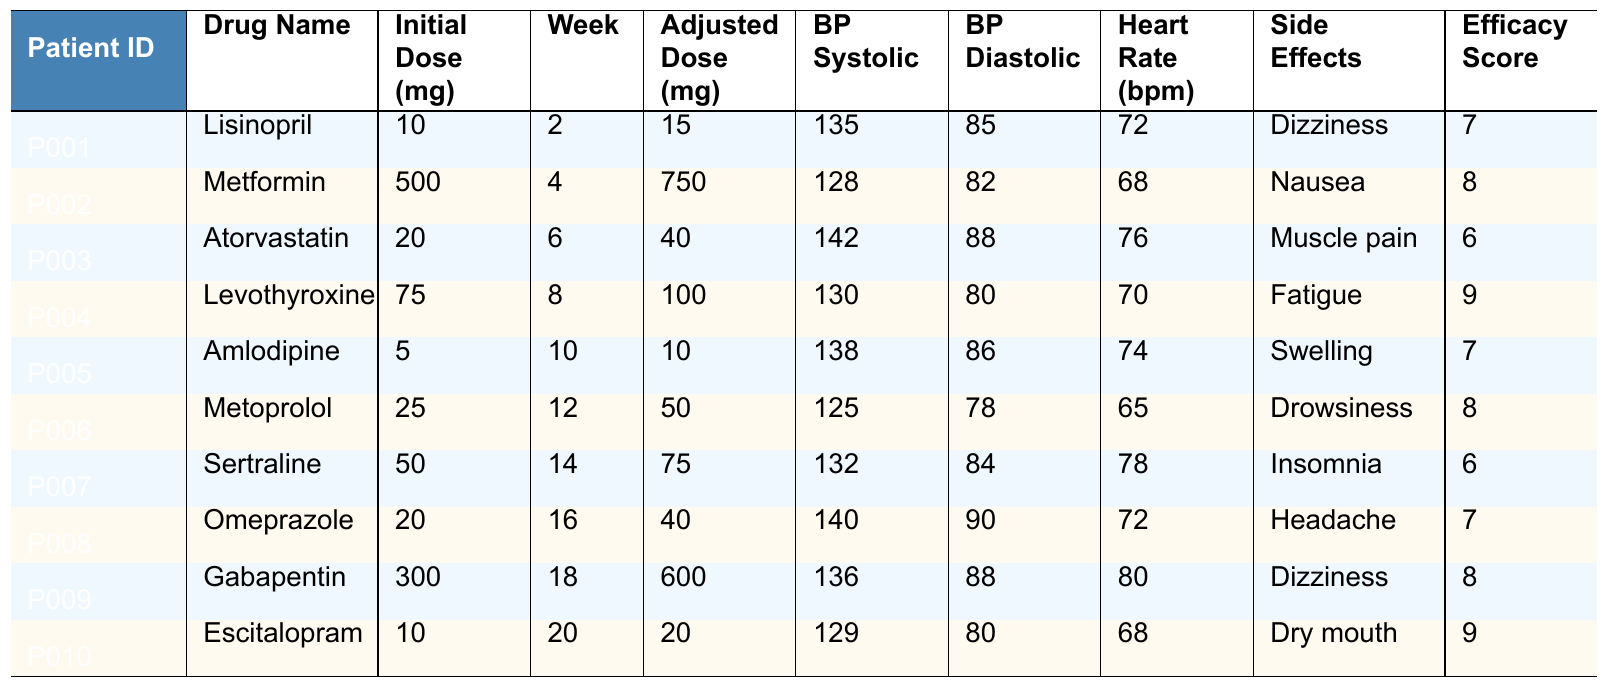What is the adjusted dose of Metformin for patient P002? The table lists the adjusted dose for Metformin (patient P002) in the "Adjusted Dose (mg)" column, which shows the value as 750 mg.
Answer: 750 mg What were the side effects reported by patient P007? In the "Side Effects" column for patient P007 (Sertraline), the entry is "Insomnia."
Answer: Insomnia Which patient experienced muscle pain and what was their efficacy score? Patient P003 experienced muscle pain as per the "Side Effects" column, and their efficacy score is noted in the "Efficacy Score" column as 6.
Answer: Muscle pain, Efficacy Score 6 What is the average initial dose of the drugs administered to patients in the trial? The initial doses are 10, 500, 20, 75, 5, 25, 50, 20, 300, and 10. Summing these gives 1015 mg. Dividing by 10 patients gives an average of 101.5 mg.
Answer: 101.5 mg Did any patients have a blood pressure diastolic value exceeding 88 mmHg? By reviewing the "BP Diastolic" column, I find that patients P003 (88), P008 (90), and P009 (88) recorded diastolic values equal to or exceeding 88 mmHg, thus the answer is yes.
Answer: Yes Who has the highest adjusted dose, and what drug were they taking? Checking the "Adjusted Dose (mg)" column, the highest value is 750 mg, which corresponds to patient P002 taking Metformin.
Answer: P002, Metformin What is the difference in diastolic blood pressure between patient P001 and patient P006? The diastolic BP for P001 is 85 mmHg and for P006 is 78 mmHg. The difference is 85 - 78 = 7 mmHg.
Answer: 7 mmHg How many patients reported dizziness as a side effect? By counting the occurrences of "Dizziness" in the "Side Effects" column, I find it appears for patient P001 and P009, totaling 2 patients.
Answer: 2 patients Is there a correlation between initial dose and efficacy score in this trial? Analyzing the "Initial Dose (mg)" and "Efficacy Score" columns shows no clear pattern; for example, P002 has a high dose but lower efficacy, indicating any correlation is weak or non-existent.
Answer: No clear correlation What is the highest efficacy score observed, and which patient achieved it? The maximum efficacy score in the "Efficacy Score" column is 9, achieved by patients P004 and P010.
Answer: 9 (Patients P004 and P010) 